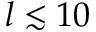Convert formula to latex. <formula><loc_0><loc_0><loc_500><loc_500>l \lesssim 1 0</formula> 